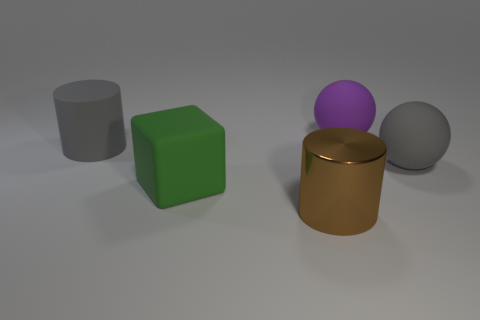Add 5 large green rubber cubes. How many objects exist? 10 Subtract 2 spheres. How many spheres are left? 0 Subtract all blocks. How many objects are left? 4 Subtract all big brown things. Subtract all green things. How many objects are left? 3 Add 3 big brown cylinders. How many big brown cylinders are left? 4 Add 1 gray cylinders. How many gray cylinders exist? 2 Subtract 0 cyan cubes. How many objects are left? 5 Subtract all yellow cylinders. Subtract all brown spheres. How many cylinders are left? 2 Subtract all blue spheres. How many gray cylinders are left? 1 